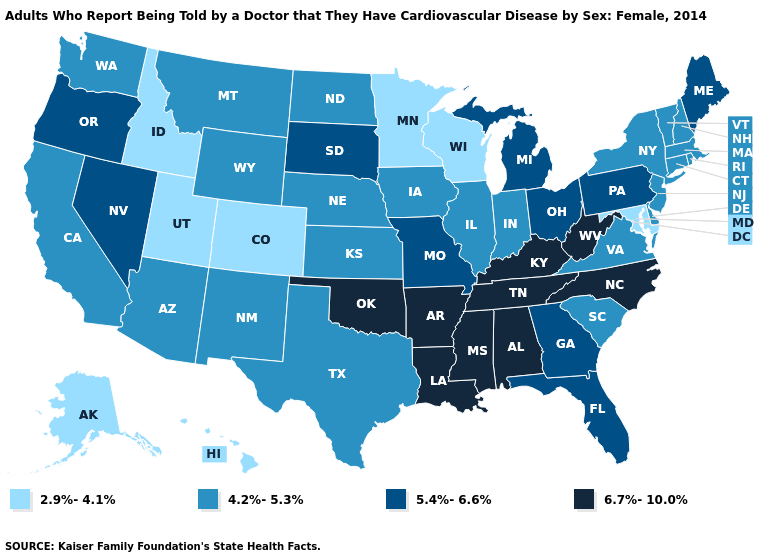Name the states that have a value in the range 2.9%-4.1%?
Give a very brief answer. Alaska, Colorado, Hawaii, Idaho, Maryland, Minnesota, Utah, Wisconsin. Among the states that border Florida , does Alabama have the highest value?
Concise answer only. Yes. Name the states that have a value in the range 6.7%-10.0%?
Be succinct. Alabama, Arkansas, Kentucky, Louisiana, Mississippi, North Carolina, Oklahoma, Tennessee, West Virginia. How many symbols are there in the legend?
Concise answer only. 4. Does North Carolina have the highest value in the USA?
Quick response, please. Yes. Does Arkansas have the highest value in the South?
Concise answer only. Yes. What is the value of Montana?
Keep it brief. 4.2%-5.3%. Name the states that have a value in the range 6.7%-10.0%?
Give a very brief answer. Alabama, Arkansas, Kentucky, Louisiana, Mississippi, North Carolina, Oklahoma, Tennessee, West Virginia. Which states have the lowest value in the USA?
Concise answer only. Alaska, Colorado, Hawaii, Idaho, Maryland, Minnesota, Utah, Wisconsin. What is the highest value in the USA?
Quick response, please. 6.7%-10.0%. Among the states that border Kentucky , does Virginia have the lowest value?
Write a very short answer. Yes. Among the states that border Nevada , does Arizona have the lowest value?
Short answer required. No. What is the lowest value in the USA?
Answer briefly. 2.9%-4.1%. Name the states that have a value in the range 6.7%-10.0%?
Give a very brief answer. Alabama, Arkansas, Kentucky, Louisiana, Mississippi, North Carolina, Oklahoma, Tennessee, West Virginia. Does Illinois have a lower value than Nebraska?
Short answer required. No. 